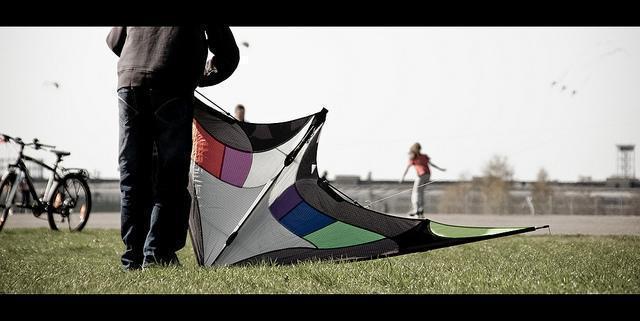How did the kite flyer get to the park?
Select the correct answer and articulate reasoning with the following format: 'Answer: answer
Rationale: rationale.'
Options: Bus, bicycle, car, wagon. Answer: bicycle.
Rationale: They rode their bike. 